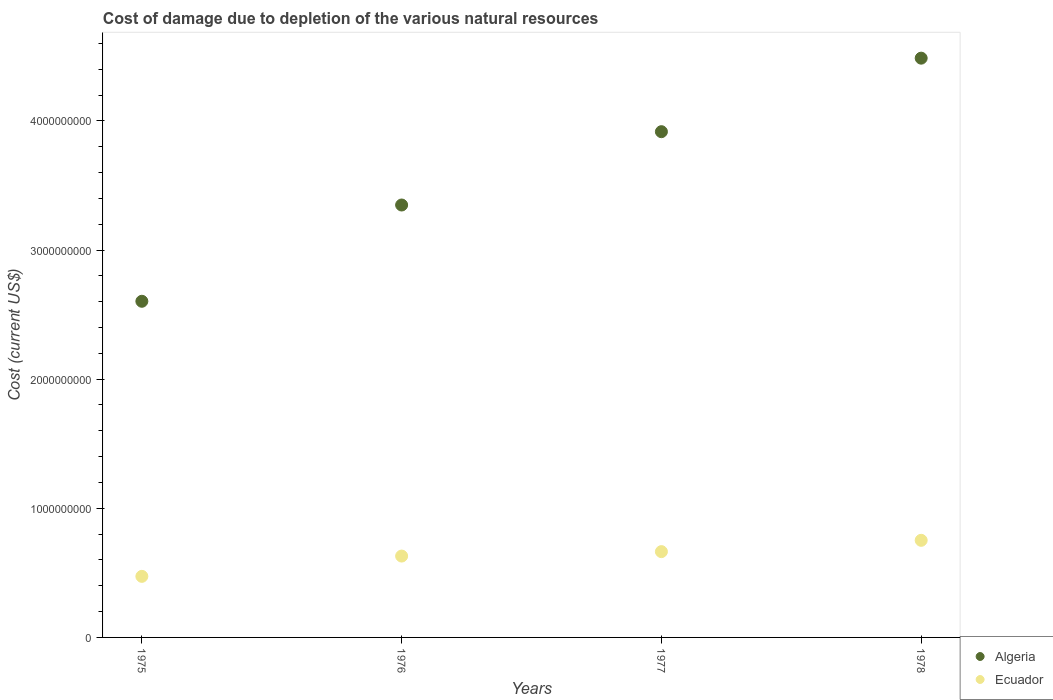Is the number of dotlines equal to the number of legend labels?
Offer a terse response. Yes. What is the cost of damage caused due to the depletion of various natural resources in Ecuador in 1976?
Offer a very short reply. 6.30e+08. Across all years, what is the maximum cost of damage caused due to the depletion of various natural resources in Ecuador?
Provide a succinct answer. 7.52e+08. Across all years, what is the minimum cost of damage caused due to the depletion of various natural resources in Ecuador?
Offer a terse response. 4.73e+08. In which year was the cost of damage caused due to the depletion of various natural resources in Algeria maximum?
Keep it short and to the point. 1978. In which year was the cost of damage caused due to the depletion of various natural resources in Algeria minimum?
Offer a very short reply. 1975. What is the total cost of damage caused due to the depletion of various natural resources in Algeria in the graph?
Make the answer very short. 1.44e+1. What is the difference between the cost of damage caused due to the depletion of various natural resources in Ecuador in 1976 and that in 1977?
Keep it short and to the point. -3.43e+07. What is the difference between the cost of damage caused due to the depletion of various natural resources in Algeria in 1976 and the cost of damage caused due to the depletion of various natural resources in Ecuador in 1977?
Your response must be concise. 2.68e+09. What is the average cost of damage caused due to the depletion of various natural resources in Algeria per year?
Keep it short and to the point. 3.59e+09. In the year 1975, what is the difference between the cost of damage caused due to the depletion of various natural resources in Algeria and cost of damage caused due to the depletion of various natural resources in Ecuador?
Keep it short and to the point. 2.13e+09. What is the ratio of the cost of damage caused due to the depletion of various natural resources in Algeria in 1975 to that in 1978?
Offer a terse response. 0.58. Is the cost of damage caused due to the depletion of various natural resources in Ecuador in 1977 less than that in 1978?
Ensure brevity in your answer.  Yes. What is the difference between the highest and the second highest cost of damage caused due to the depletion of various natural resources in Algeria?
Provide a short and direct response. 5.69e+08. What is the difference between the highest and the lowest cost of damage caused due to the depletion of various natural resources in Algeria?
Offer a terse response. 1.88e+09. Does the cost of damage caused due to the depletion of various natural resources in Ecuador monotonically increase over the years?
Keep it short and to the point. Yes. Is the cost of damage caused due to the depletion of various natural resources in Ecuador strictly less than the cost of damage caused due to the depletion of various natural resources in Algeria over the years?
Your answer should be compact. Yes. How many dotlines are there?
Your answer should be very brief. 2. How many years are there in the graph?
Offer a very short reply. 4. What is the difference between two consecutive major ticks on the Y-axis?
Provide a succinct answer. 1.00e+09. Are the values on the major ticks of Y-axis written in scientific E-notation?
Make the answer very short. No. Does the graph contain any zero values?
Your answer should be very brief. No. Does the graph contain grids?
Offer a very short reply. No. Where does the legend appear in the graph?
Give a very brief answer. Bottom right. How are the legend labels stacked?
Offer a very short reply. Vertical. What is the title of the graph?
Your response must be concise. Cost of damage due to depletion of the various natural resources. What is the label or title of the Y-axis?
Offer a very short reply. Cost (current US$). What is the Cost (current US$) of Algeria in 1975?
Provide a succinct answer. 2.60e+09. What is the Cost (current US$) in Ecuador in 1975?
Keep it short and to the point. 4.73e+08. What is the Cost (current US$) of Algeria in 1976?
Your answer should be very brief. 3.35e+09. What is the Cost (current US$) in Ecuador in 1976?
Ensure brevity in your answer.  6.30e+08. What is the Cost (current US$) in Algeria in 1977?
Your answer should be compact. 3.92e+09. What is the Cost (current US$) in Ecuador in 1977?
Make the answer very short. 6.64e+08. What is the Cost (current US$) in Algeria in 1978?
Give a very brief answer. 4.49e+09. What is the Cost (current US$) in Ecuador in 1978?
Your response must be concise. 7.52e+08. Across all years, what is the maximum Cost (current US$) in Algeria?
Your answer should be very brief. 4.49e+09. Across all years, what is the maximum Cost (current US$) of Ecuador?
Provide a succinct answer. 7.52e+08. Across all years, what is the minimum Cost (current US$) in Algeria?
Your answer should be compact. 2.60e+09. Across all years, what is the minimum Cost (current US$) in Ecuador?
Offer a terse response. 4.73e+08. What is the total Cost (current US$) in Algeria in the graph?
Your answer should be compact. 1.44e+1. What is the total Cost (current US$) of Ecuador in the graph?
Your answer should be very brief. 2.52e+09. What is the difference between the Cost (current US$) of Algeria in 1975 and that in 1976?
Ensure brevity in your answer.  -7.46e+08. What is the difference between the Cost (current US$) in Ecuador in 1975 and that in 1976?
Offer a terse response. -1.57e+08. What is the difference between the Cost (current US$) of Algeria in 1975 and that in 1977?
Give a very brief answer. -1.31e+09. What is the difference between the Cost (current US$) in Ecuador in 1975 and that in 1977?
Offer a terse response. -1.91e+08. What is the difference between the Cost (current US$) of Algeria in 1975 and that in 1978?
Give a very brief answer. -1.88e+09. What is the difference between the Cost (current US$) in Ecuador in 1975 and that in 1978?
Your answer should be compact. -2.79e+08. What is the difference between the Cost (current US$) in Algeria in 1976 and that in 1977?
Ensure brevity in your answer.  -5.68e+08. What is the difference between the Cost (current US$) in Ecuador in 1976 and that in 1977?
Offer a terse response. -3.43e+07. What is the difference between the Cost (current US$) in Algeria in 1976 and that in 1978?
Give a very brief answer. -1.14e+09. What is the difference between the Cost (current US$) of Ecuador in 1976 and that in 1978?
Offer a very short reply. -1.22e+08. What is the difference between the Cost (current US$) in Algeria in 1977 and that in 1978?
Give a very brief answer. -5.69e+08. What is the difference between the Cost (current US$) in Ecuador in 1977 and that in 1978?
Provide a short and direct response. -8.76e+07. What is the difference between the Cost (current US$) of Algeria in 1975 and the Cost (current US$) of Ecuador in 1976?
Your answer should be compact. 1.97e+09. What is the difference between the Cost (current US$) of Algeria in 1975 and the Cost (current US$) of Ecuador in 1977?
Offer a very short reply. 1.94e+09. What is the difference between the Cost (current US$) in Algeria in 1975 and the Cost (current US$) in Ecuador in 1978?
Your answer should be very brief. 1.85e+09. What is the difference between the Cost (current US$) in Algeria in 1976 and the Cost (current US$) in Ecuador in 1977?
Give a very brief answer. 2.68e+09. What is the difference between the Cost (current US$) of Algeria in 1976 and the Cost (current US$) of Ecuador in 1978?
Give a very brief answer. 2.60e+09. What is the difference between the Cost (current US$) in Algeria in 1977 and the Cost (current US$) in Ecuador in 1978?
Ensure brevity in your answer.  3.16e+09. What is the average Cost (current US$) of Algeria per year?
Provide a succinct answer. 3.59e+09. What is the average Cost (current US$) in Ecuador per year?
Ensure brevity in your answer.  6.30e+08. In the year 1975, what is the difference between the Cost (current US$) in Algeria and Cost (current US$) in Ecuador?
Make the answer very short. 2.13e+09. In the year 1976, what is the difference between the Cost (current US$) of Algeria and Cost (current US$) of Ecuador?
Make the answer very short. 2.72e+09. In the year 1977, what is the difference between the Cost (current US$) in Algeria and Cost (current US$) in Ecuador?
Provide a succinct answer. 3.25e+09. In the year 1978, what is the difference between the Cost (current US$) of Algeria and Cost (current US$) of Ecuador?
Your answer should be compact. 3.73e+09. What is the ratio of the Cost (current US$) of Algeria in 1975 to that in 1976?
Your response must be concise. 0.78. What is the ratio of the Cost (current US$) of Ecuador in 1975 to that in 1976?
Offer a terse response. 0.75. What is the ratio of the Cost (current US$) in Algeria in 1975 to that in 1977?
Make the answer very short. 0.66. What is the ratio of the Cost (current US$) in Ecuador in 1975 to that in 1977?
Your response must be concise. 0.71. What is the ratio of the Cost (current US$) in Algeria in 1975 to that in 1978?
Provide a short and direct response. 0.58. What is the ratio of the Cost (current US$) of Ecuador in 1975 to that in 1978?
Provide a short and direct response. 0.63. What is the ratio of the Cost (current US$) of Algeria in 1976 to that in 1977?
Your answer should be compact. 0.85. What is the ratio of the Cost (current US$) in Ecuador in 1976 to that in 1977?
Offer a terse response. 0.95. What is the ratio of the Cost (current US$) in Algeria in 1976 to that in 1978?
Offer a very short reply. 0.75. What is the ratio of the Cost (current US$) in Ecuador in 1976 to that in 1978?
Provide a succinct answer. 0.84. What is the ratio of the Cost (current US$) of Algeria in 1977 to that in 1978?
Your answer should be compact. 0.87. What is the ratio of the Cost (current US$) in Ecuador in 1977 to that in 1978?
Give a very brief answer. 0.88. What is the difference between the highest and the second highest Cost (current US$) of Algeria?
Offer a terse response. 5.69e+08. What is the difference between the highest and the second highest Cost (current US$) of Ecuador?
Your answer should be compact. 8.76e+07. What is the difference between the highest and the lowest Cost (current US$) in Algeria?
Provide a short and direct response. 1.88e+09. What is the difference between the highest and the lowest Cost (current US$) in Ecuador?
Give a very brief answer. 2.79e+08. 